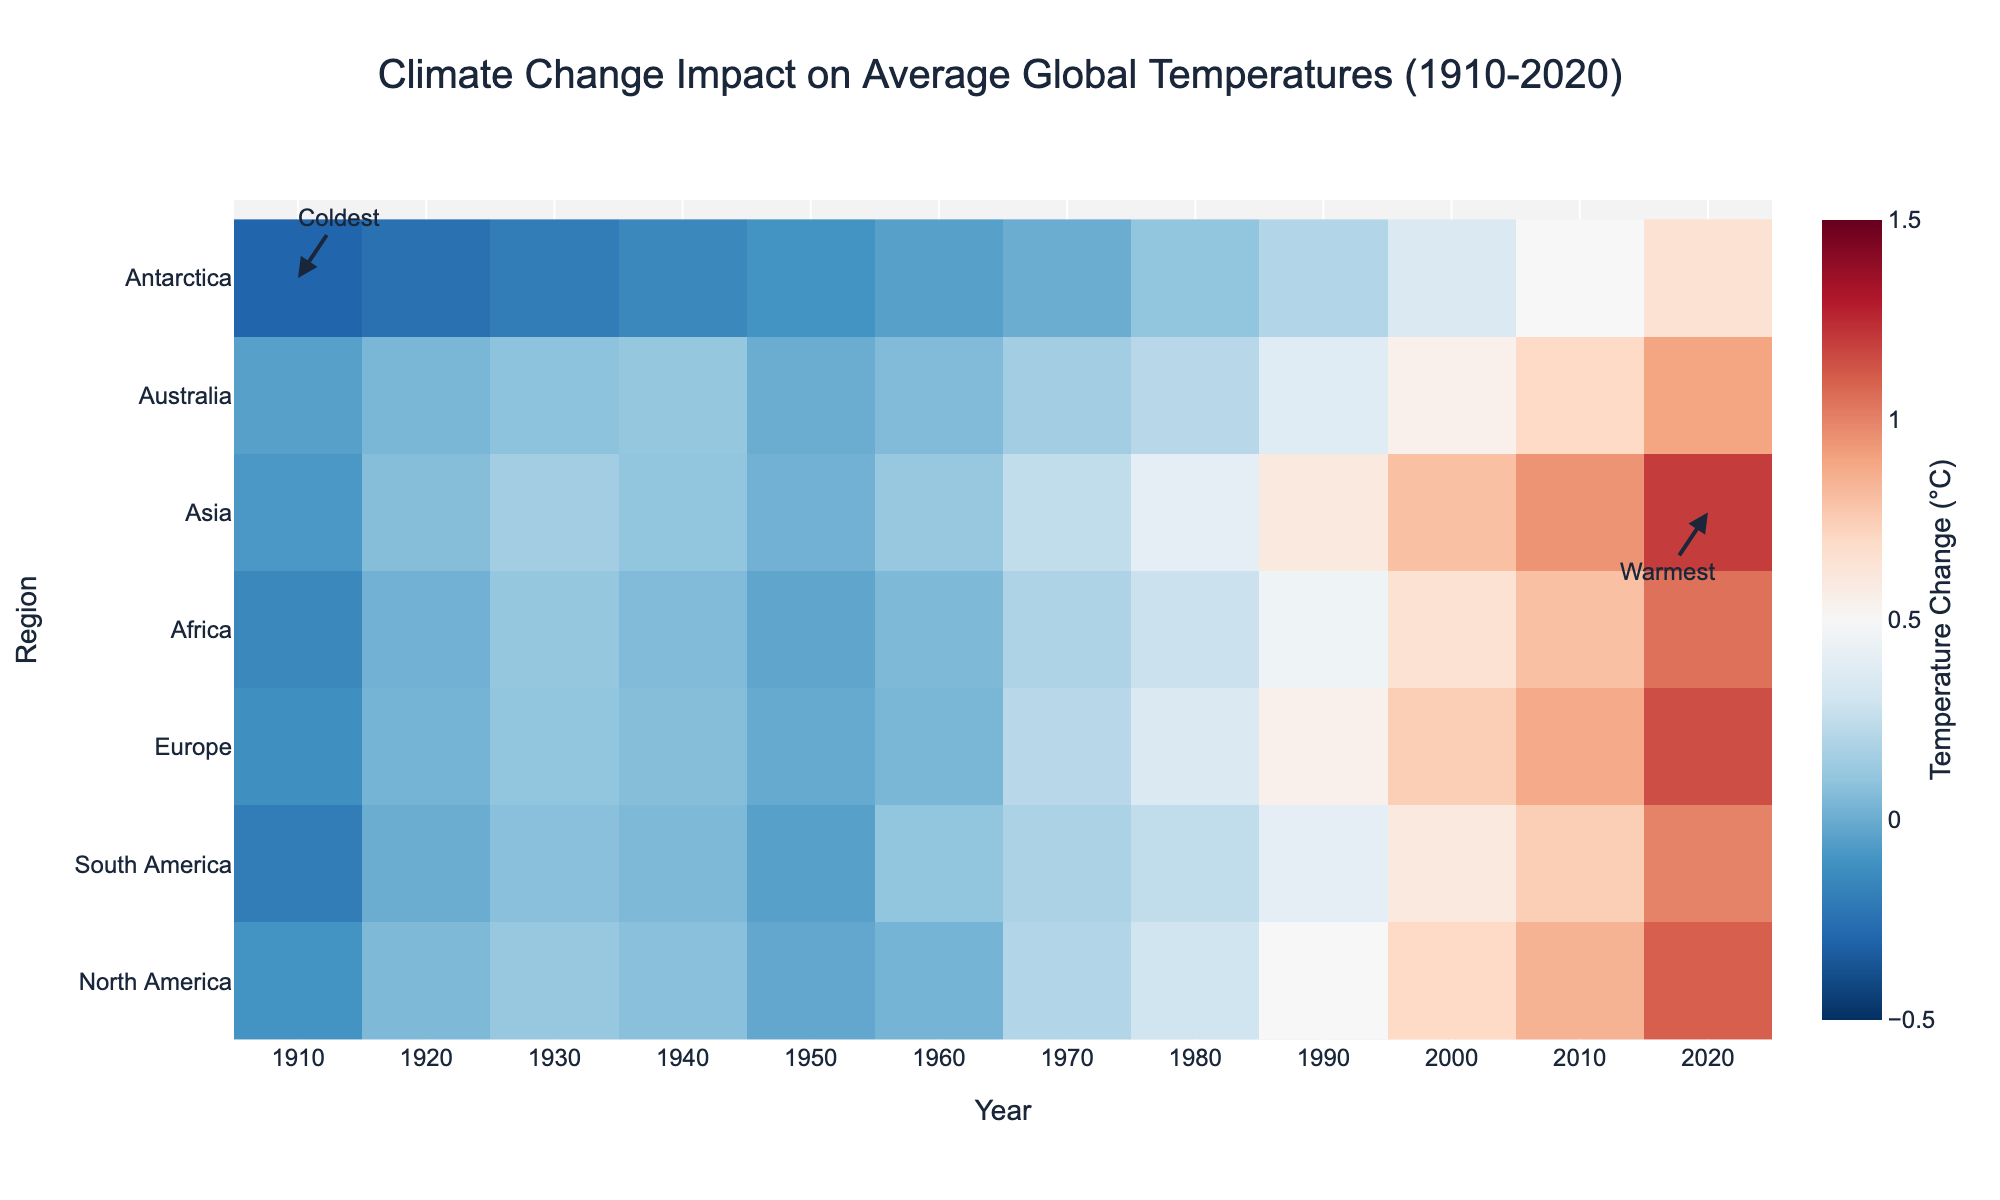What's the title of the figure? The title is located at the top of the figure and provides a summary of what the figure represents.
Answer: Climate Change Impact on Average Global Temperatures (1910-2020) Which region shows the highest temperature increase in 2020? Looking at the heatmap for the year 2020, identify the region with the darkest red color.
Answer: Asia What is the general trend of temperature change in North America from 1910 to 2020? Examine the progression of colors in the row corresponding to North America from 1910 to 2020 and summarize the change.
Answer: Increasing For which region does the heatmap indicate the most consistent rise in temperature across the years? Analyze the color gradient for each region’s row over the years and identify the one with the most consistent shift from blue to red.
Answer: Asia Between which years did Europe experience its most significant temperature increase? Find the time period in Europe’s row where the color shifts most dramatically from blue to red.
Answer: 1980 to 1990 How does the temperature change in Antarctica compare to other regions by 2020? Look at the color of Antarctica’s region in 2020 and compare it to other regions' colors in the same year.
Answer: Less What is the temperature change in South America in 1920? Refer to the color or the value corresponding to the year 1920 in South America's row.
Answer: 0.00°C Which decade shows the first noticeable warming in Australia? Identify the decade in Australia’s row that shows a shift from blue to red.
Answer: 1980s In which year did Africa’s temperature reach a 0.65°C increase? Look for the year in Africa’s row where the color corresponds to a 0.65°C change.
Answer: 2000 Which region was the coldest in 1910, based on the heatmap? Check the color in 1910 for all regions and identify the one with the darkest blue.
Answer: Antarctica 